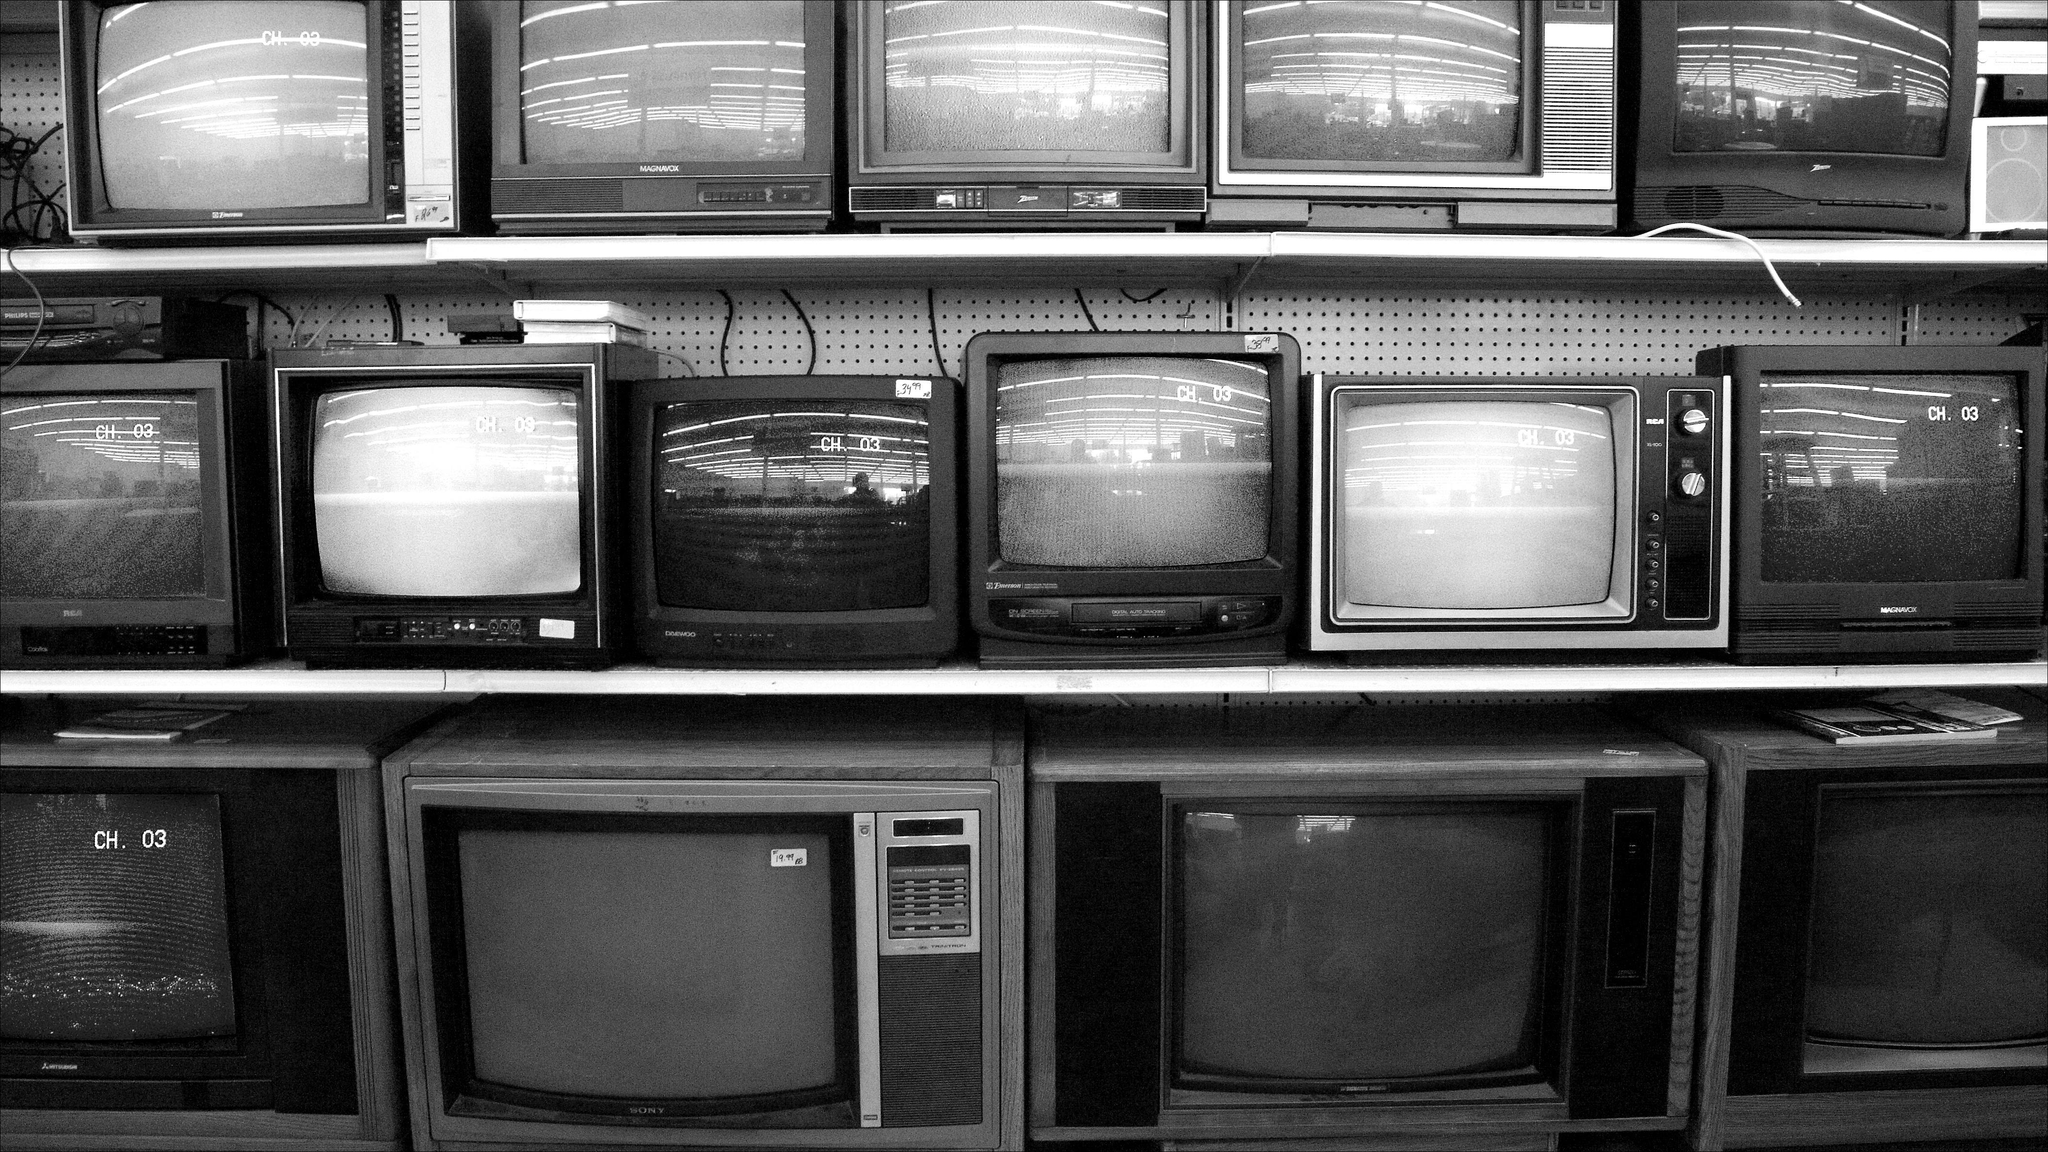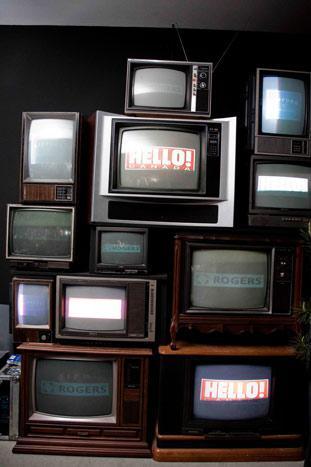The first image is the image on the left, the second image is the image on the right. Assess this claim about the two images: "The televisions in the left image appear to be powered on.". Correct or not? Answer yes or no. No. The first image is the image on the left, the second image is the image on the right. Analyze the images presented: Is the assertion "in at least one image there is a stack of tv's in a half moon shape" valid? Answer yes or no. No. 